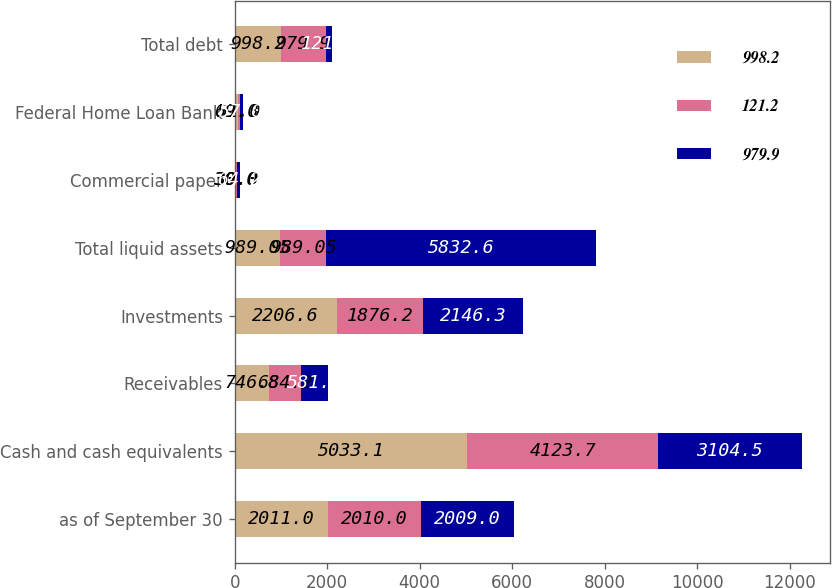Convert chart to OTSL. <chart><loc_0><loc_0><loc_500><loc_500><stacked_bar_chart><ecel><fcel>as of September 30<fcel>Cash and cash equivalents<fcel>Receivables<fcel>Investments<fcel>Total liquid assets<fcel>Commercial paper<fcel>Federal Home Loan Bank<fcel>Total debt<nl><fcel>998.2<fcel>2011<fcel>5033.1<fcel>746.8<fcel>2206.6<fcel>989.05<fcel>30<fcel>69<fcel>998.2<nl><fcel>121.2<fcel>2010<fcel>4123.7<fcel>684.2<fcel>1876.2<fcel>989.05<fcel>30<fcel>51<fcel>979.9<nl><fcel>979.9<fcel>2009<fcel>3104.5<fcel>581.8<fcel>2146.3<fcel>5832.6<fcel>64.2<fcel>57<fcel>121.2<nl></chart> 